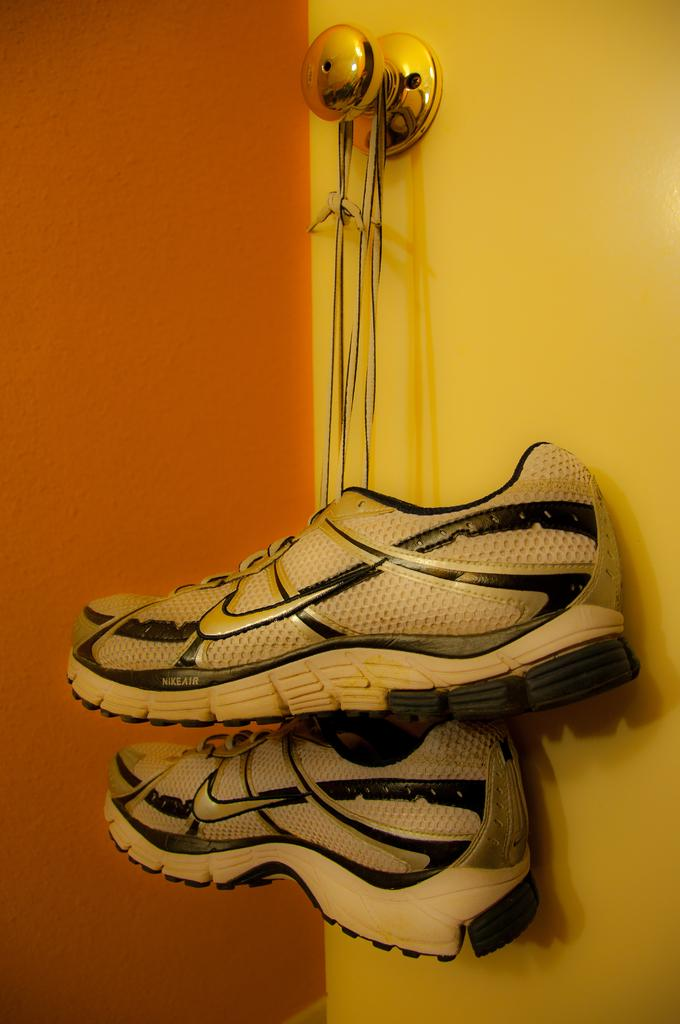What is the main subject of the image? The main subject of the image is a pair of shoes. Where are the shoes located in the image? The shoes are hanging on a door. What can be seen in the background of the image? There is a wall visible in the background of the image. What verse is written on the shoes in the image? There is no verse written on the shoes in the image; they are just a pair of shoes hanging on a door. 